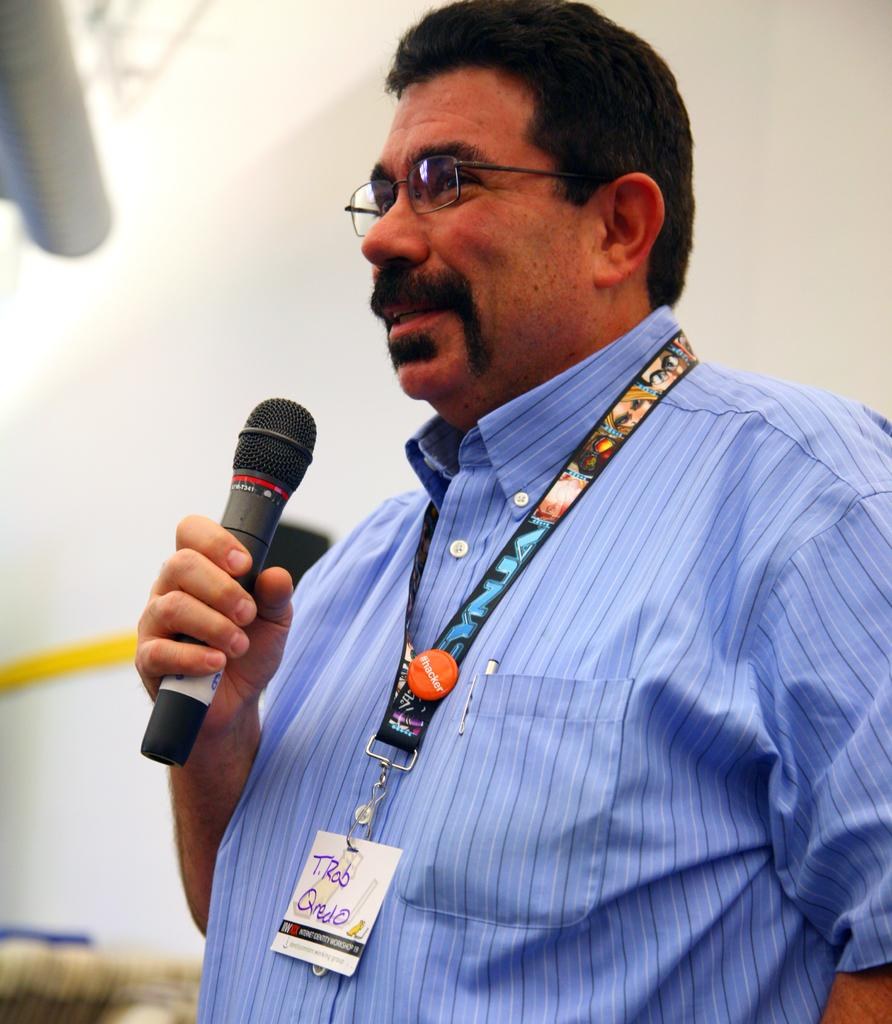Who is the main subject in the image? There is a man in the image. What is the man holding in his hand? The man is holding a mic in his hand. Can you describe any additional items the man is wearing? The man is wearing an id card. What type of soup is being served in the image? There is no soup present in the image. What type of expansion is visible in the image? There is no expansion visible in the image. 